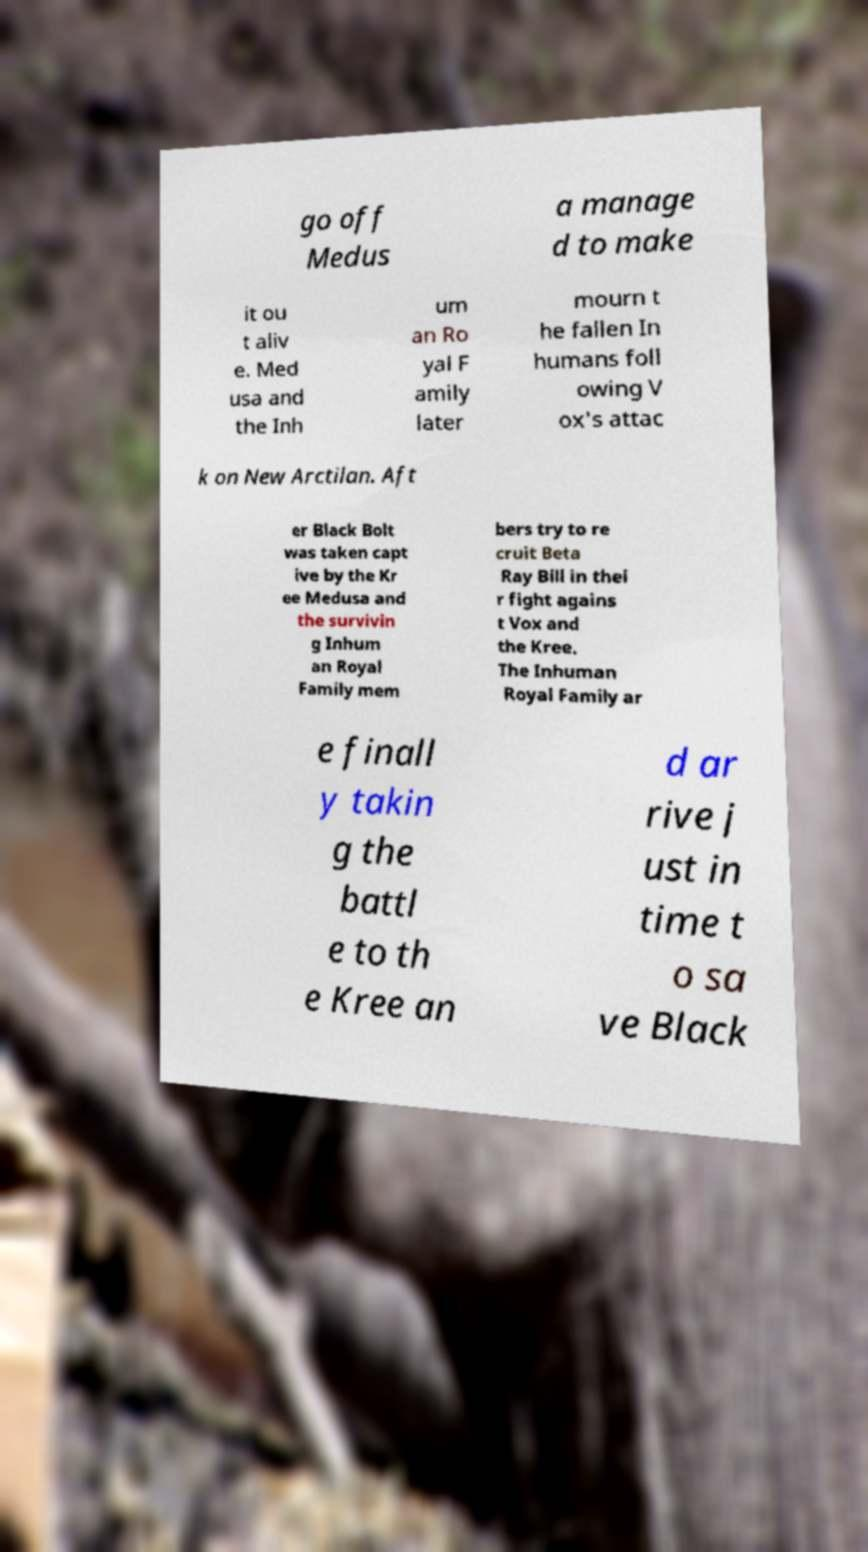Please read and relay the text visible in this image. What does it say? go off Medus a manage d to make it ou t aliv e. Med usa and the Inh um an Ro yal F amily later mourn t he fallen In humans foll owing V ox's attac k on New Arctilan. Aft er Black Bolt was taken capt ive by the Kr ee Medusa and the survivin g Inhum an Royal Family mem bers try to re cruit Beta Ray Bill in thei r fight agains t Vox and the Kree. The Inhuman Royal Family ar e finall y takin g the battl e to th e Kree an d ar rive j ust in time t o sa ve Black 